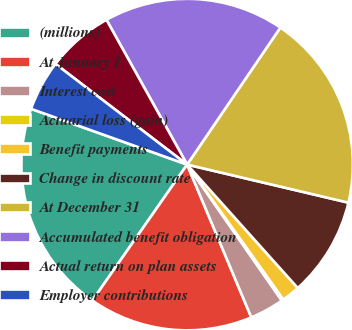Convert chart. <chart><loc_0><loc_0><loc_500><loc_500><pie_chart><fcel>(millions)<fcel>At January 1<fcel>Interest cost<fcel>Actuarial loss (gain)<fcel>Benefit payments<fcel>Change in discount rate<fcel>At December 31<fcel>Accumulated benefit obligation<fcel>Actual return on plan assets<fcel>Employer contributions<nl><fcel>20.77%<fcel>16.02%<fcel>3.35%<fcel>0.18%<fcel>1.77%<fcel>9.68%<fcel>19.18%<fcel>17.6%<fcel>6.52%<fcel>4.93%<nl></chart> 